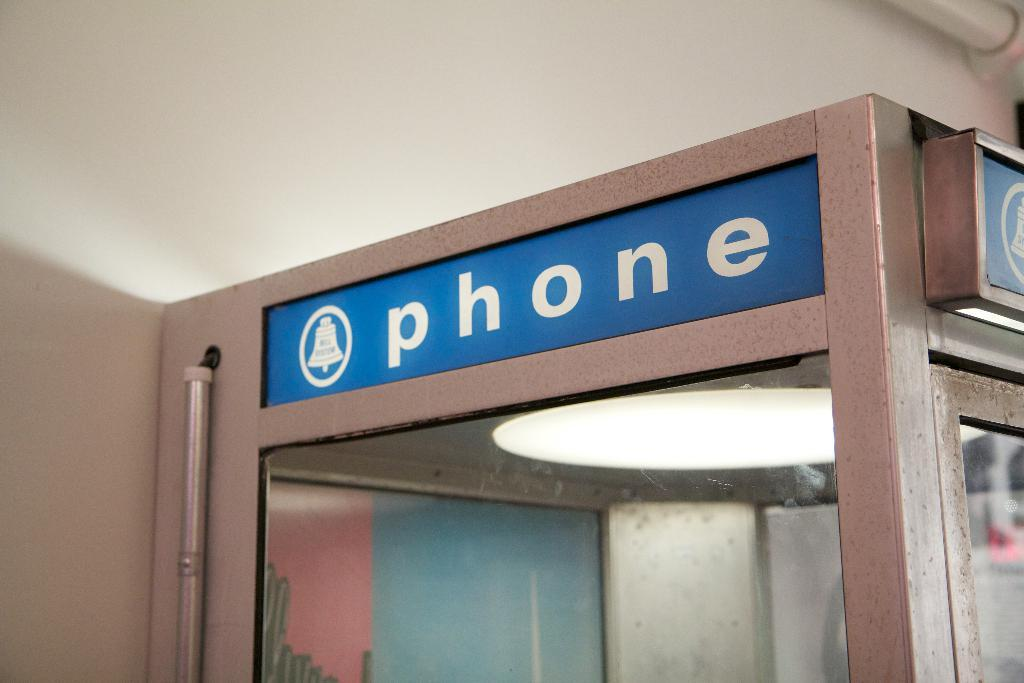What is the main structure in the image? There is a pole in the image. What else can be seen attached to the pole? There are boards in the image, which are likely attached to the pole. Is there any source of illumination in the image? Yes, there is a light in the image. What type of background is visible in the image? There is a wall in the image. How does the wind affect the parent's back in the image? There is no wind, parent, or back present in the image. 